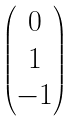<formula> <loc_0><loc_0><loc_500><loc_500>\begin{pmatrix} 0 \\ 1 \\ - 1 \end{pmatrix}</formula> 